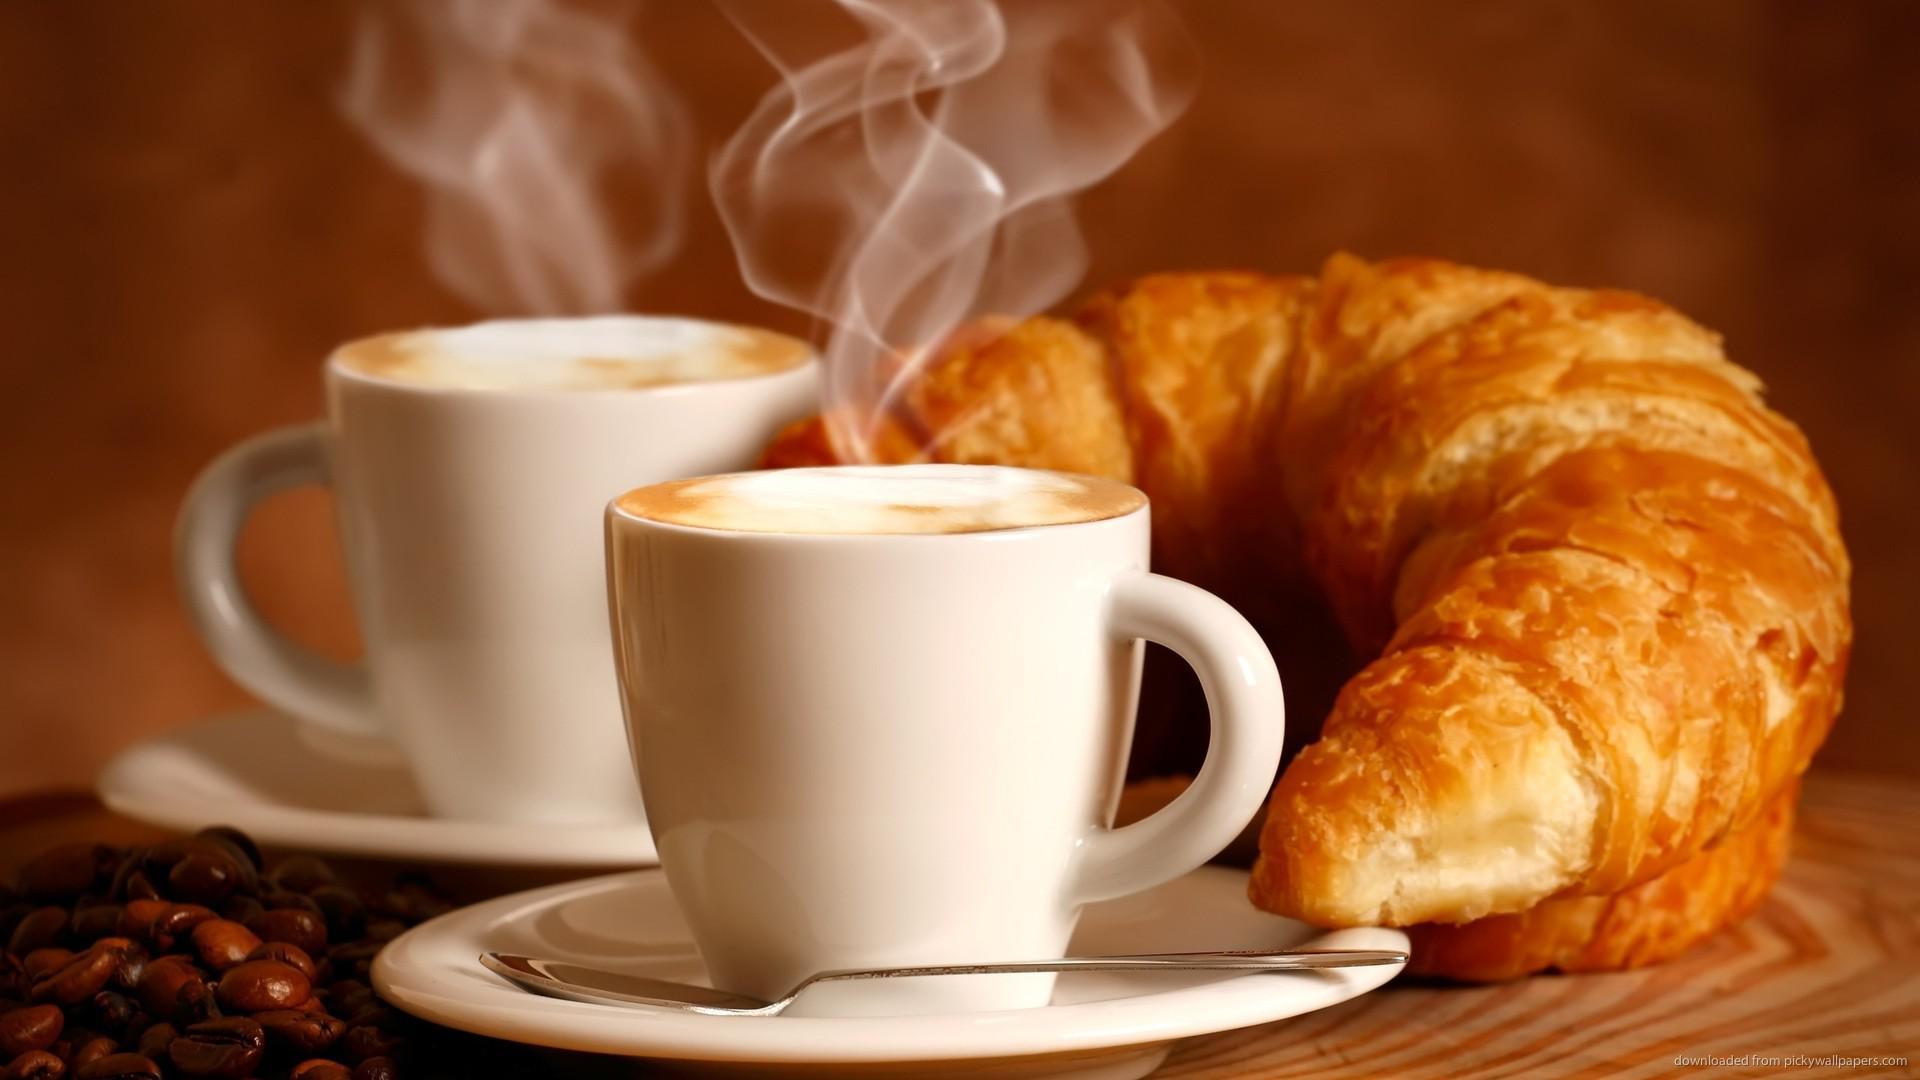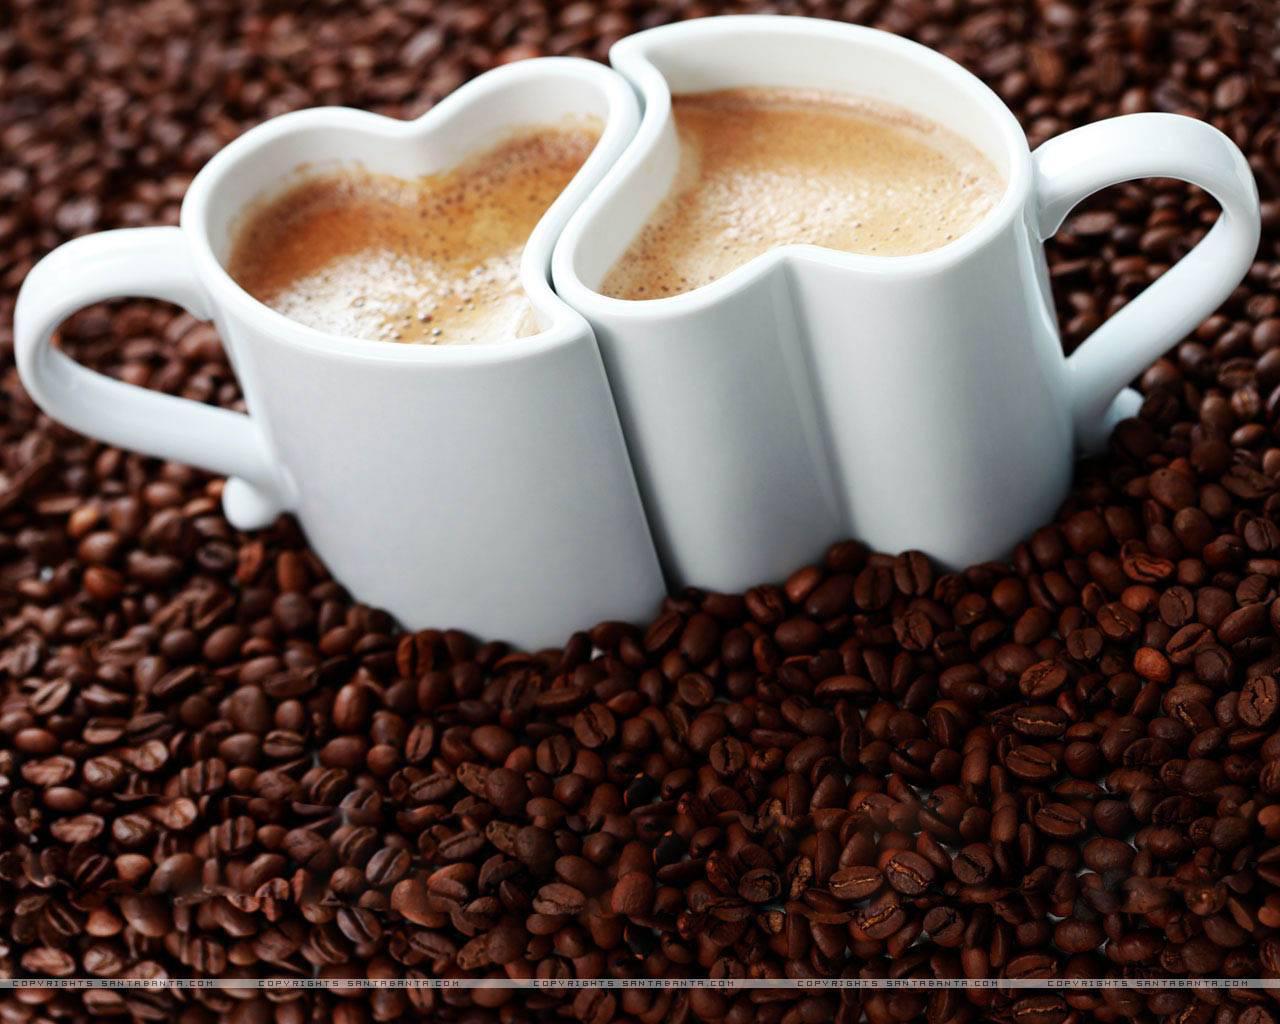The first image is the image on the left, the second image is the image on the right. Given the left and right images, does the statement "A pair of white cups sit on a folded woven beige cloth with a scattering of coffee beans on it." hold true? Answer yes or no. No. 